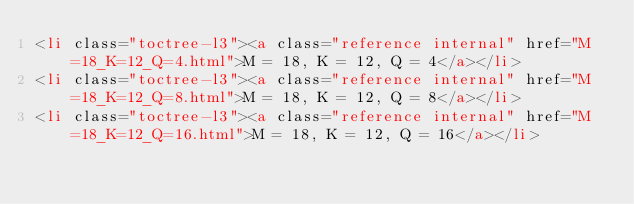<code> <loc_0><loc_0><loc_500><loc_500><_HTML_><li class="toctree-l3"><a class="reference internal" href="M=18_K=12_Q=4.html">M = 18, K = 12, Q = 4</a></li>
<li class="toctree-l3"><a class="reference internal" href="M=18_K=12_Q=8.html">M = 18, K = 12, Q = 8</a></li>
<li class="toctree-l3"><a class="reference internal" href="M=18_K=12_Q=16.html">M = 18, K = 12, Q = 16</a></li></code> 